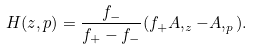<formula> <loc_0><loc_0><loc_500><loc_500>H ( z , p ) = \frac { f _ { - } } { f _ { + } - f _ { - } } ( f _ { + } A , _ { z } - A , _ { p } ) .</formula> 